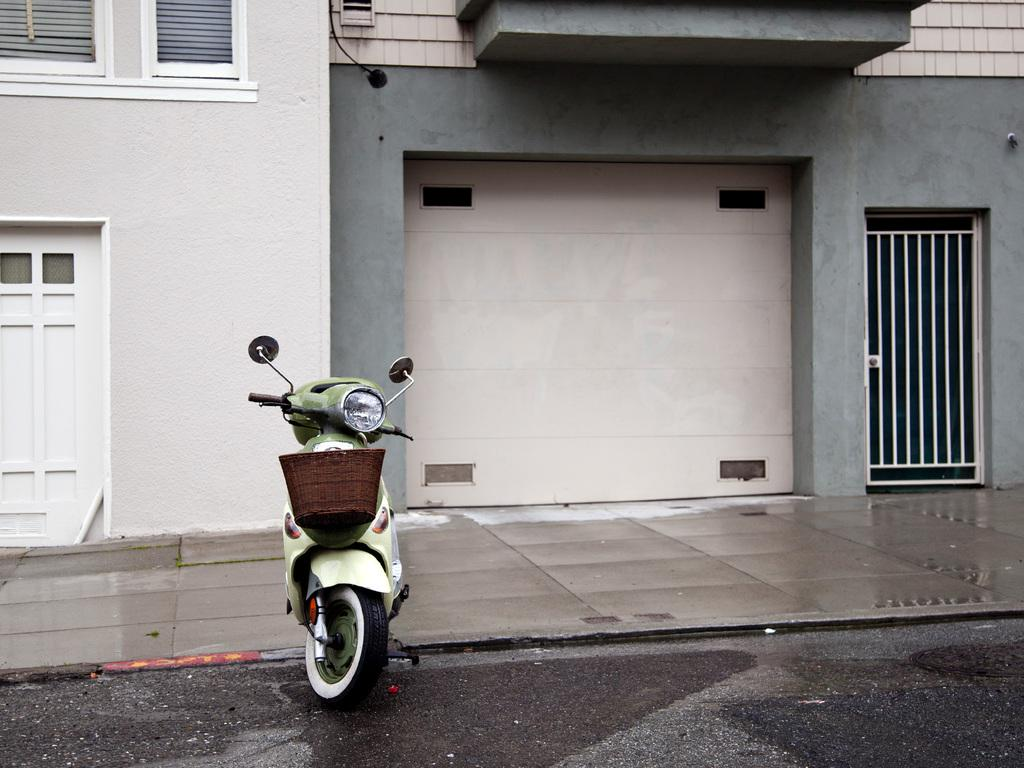What type of vehicle is in the image? There is a scooter in the image. What type of structure is near the scooter? There is a building with windows in the image. What are the access points to the building? The building has a door and a gate in the image. What type of path is near the building? There is a sidewalk near the building in the image. What does the donkey taste like in the image? There is no donkey present in the image, so it is not possible to determine its taste. 